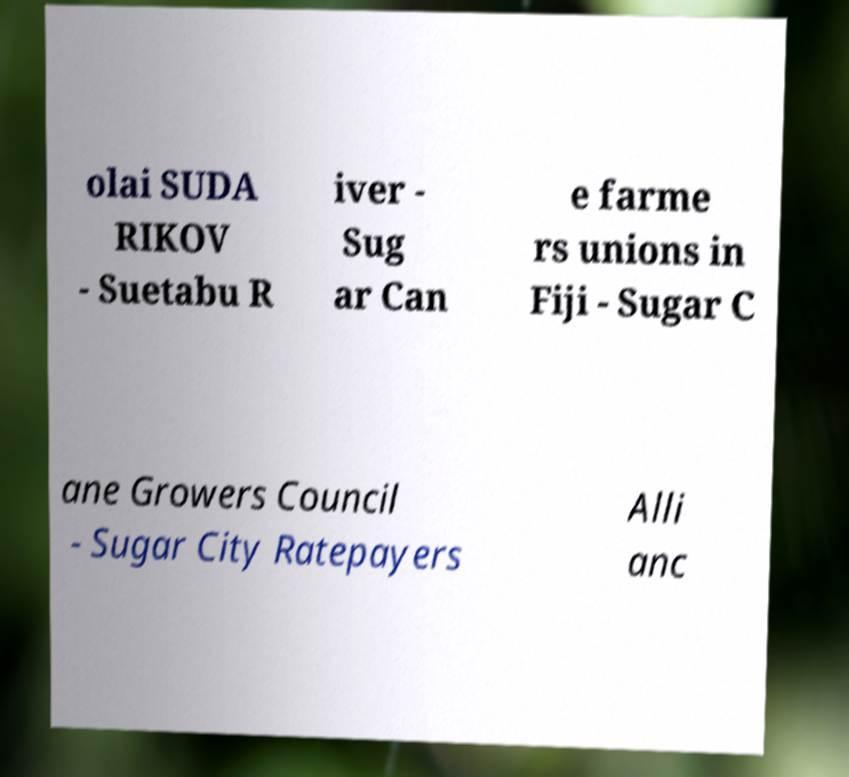Could you assist in decoding the text presented in this image and type it out clearly? olai SUDA RIKOV - Suetabu R iver - Sug ar Can e farme rs unions in Fiji - Sugar C ane Growers Council - Sugar City Ratepayers Alli anc 